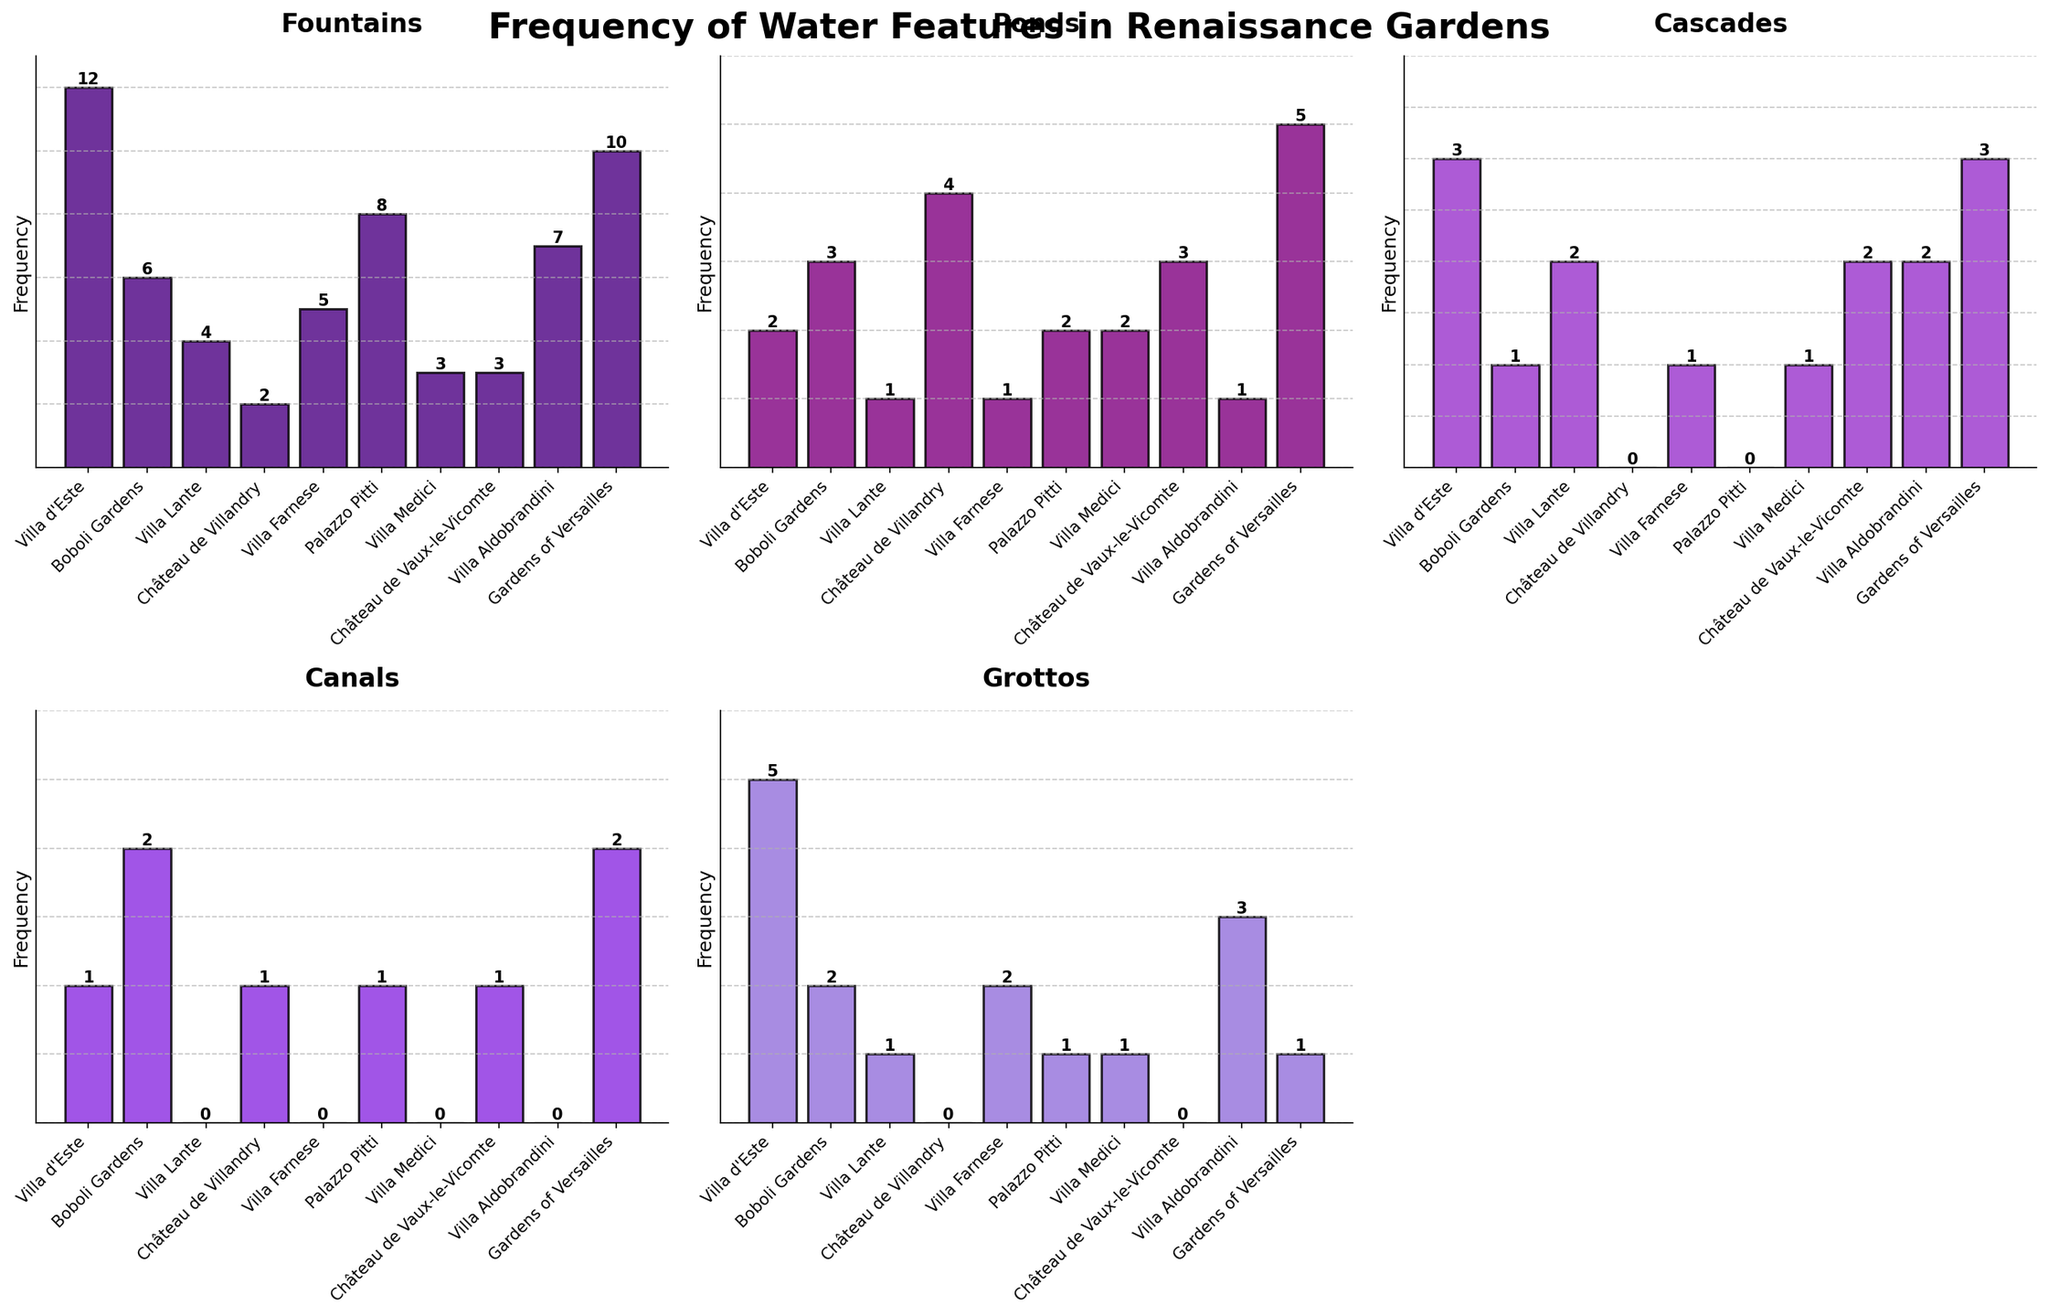How many gardens have fountains as the most frequent water feature? To determine this, look for gardens where the height of the bar for fountains is greater than the other water feature bars for that garden.
Answer: 6 Which garden has the greatest number of grottos? Identify the garden with the tallest bar in the Grottos subplot.
Answer: Villa d'Este Which water feature is the most common across all gardens? Compare the heights of the tallest bars in each subplot to find the water feature with the highest peak.
Answer: Fountains What is the range of cascades present in the gardens? Find the highest and lowest values of cascades, then calculate the difference between them. The highest is 3, and the lowest is 0.
Answer: 3 If you sum the total number of ponds across all gardens, what is the result? Add up all the values in the Ponds subplot. The values are 2 + 3 + 1 + 4 + 1 + 2 + 2 + 3 + 1 + 5.
Answer: 24 Which garden has the lowest frequency of canals? Identify the garden with the shortest bar in the Canals subplot. Multiple gardens have zero canals.
Answer: Villa Lante, Villa Farnese, Villa Medici, Villa Aldobrandini Are there any gardens where cascades and grottos have the same frequency? If yes, name them. Look for bars in the Cascades and Grottos subplots that are of equal height within the same garden.
Answer: Villa d'Este, Villa Lante Which garden has the second highest number of fountains? First, find the garden with the highest number of fountains (Villa d'Este), then look for the garden with the next tallest bar in the Fountains subplot.
Answer: Gardens of Versailles What is the average number of canals across all gardens? Sum up all the canal frequencies and divide by the number of gardens (1 + 2 + 0 + 1 + 0 + 1 + 0 + 1 + 0 + 2) = 8, divide by 10.
Answer: 0.8 Compare the total number of ponds to grottos across all gardens. Which is higher? Sum the values for ponds and grottos and compare them. Total ponds: 24, total grottos: 15.
Answer: Ponds 